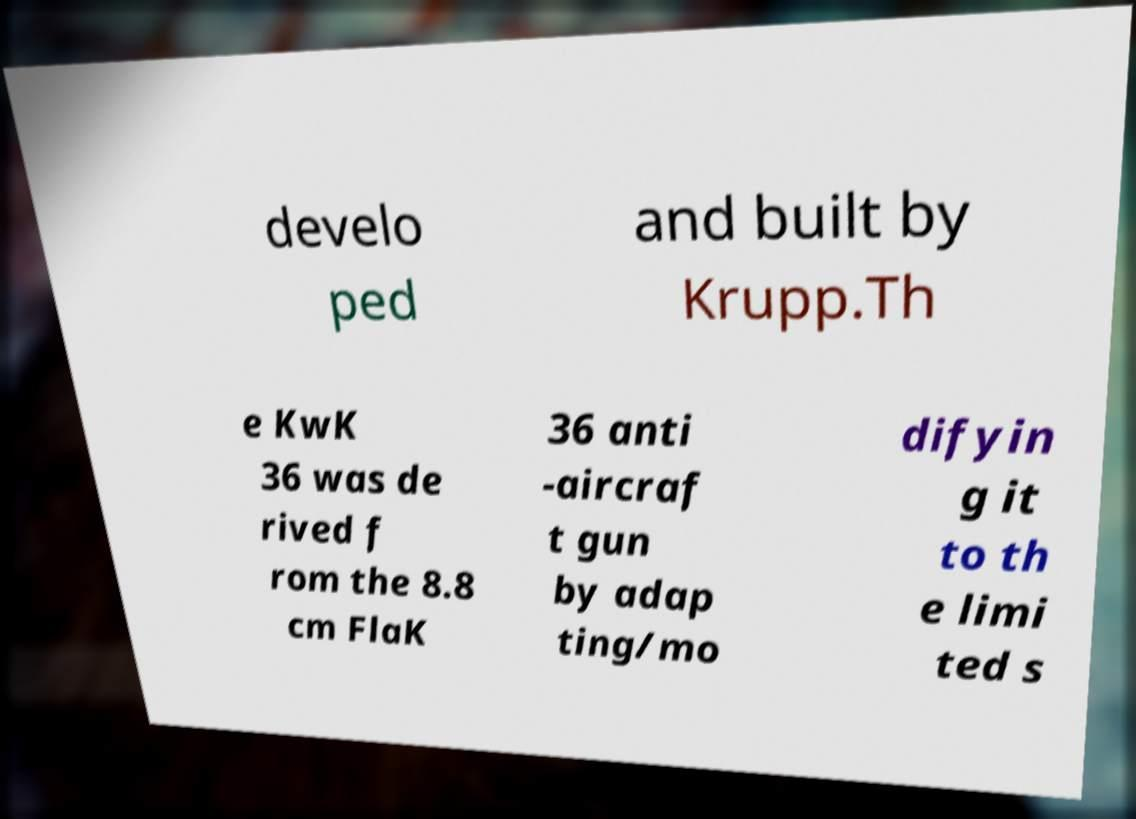Can you accurately transcribe the text from the provided image for me? develo ped and built by Krupp.Th e KwK 36 was de rived f rom the 8.8 cm FlaK 36 anti -aircraf t gun by adap ting/mo difyin g it to th e limi ted s 